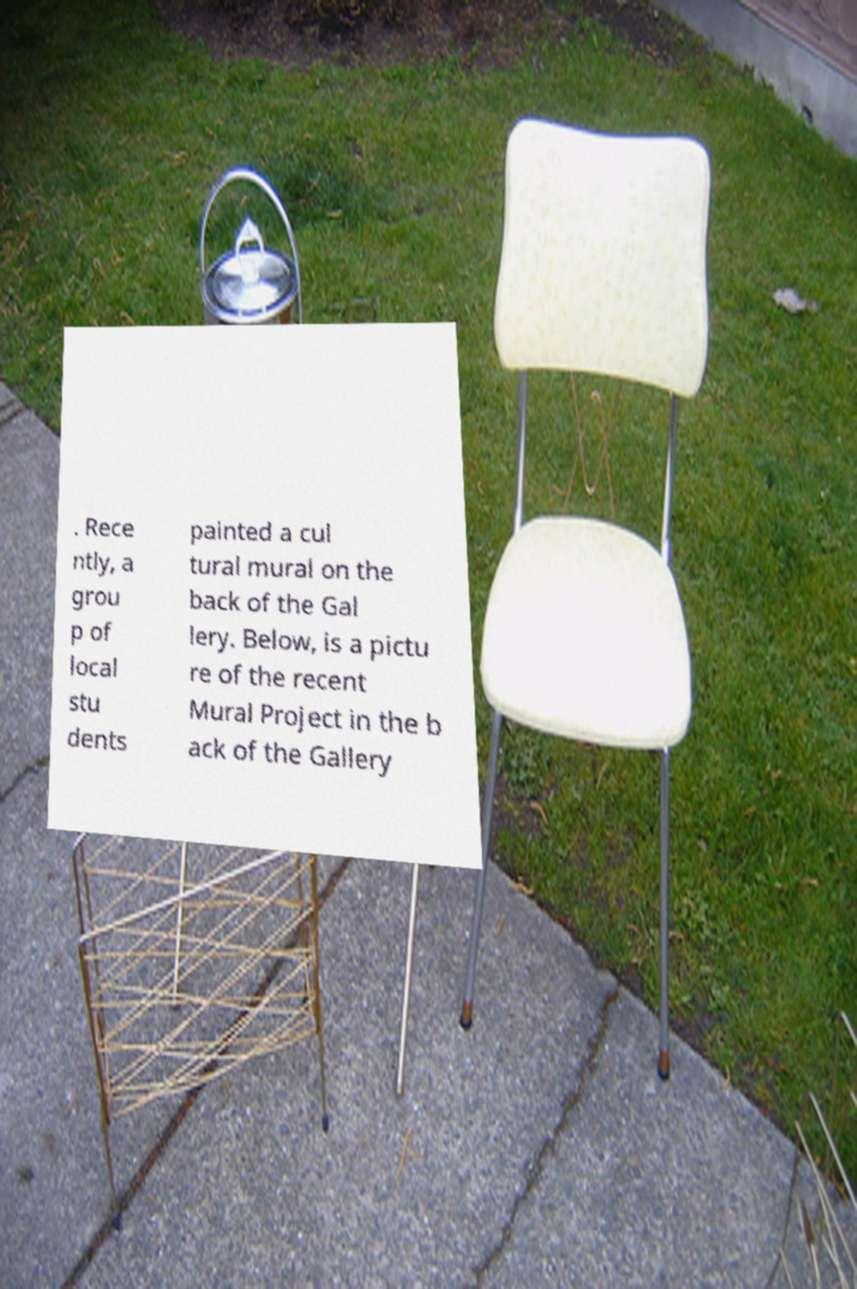Can you read and provide the text displayed in the image?This photo seems to have some interesting text. Can you extract and type it out for me? . Rece ntly, a grou p of local stu dents painted a cul tural mural on the back of the Gal lery. Below, is a pictu re of the recent Mural Project in the b ack of the Gallery 